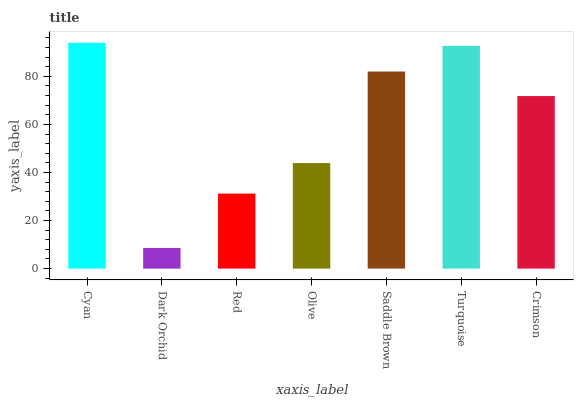Is Dark Orchid the minimum?
Answer yes or no. Yes. Is Cyan the maximum?
Answer yes or no. Yes. Is Red the minimum?
Answer yes or no. No. Is Red the maximum?
Answer yes or no. No. Is Red greater than Dark Orchid?
Answer yes or no. Yes. Is Dark Orchid less than Red?
Answer yes or no. Yes. Is Dark Orchid greater than Red?
Answer yes or no. No. Is Red less than Dark Orchid?
Answer yes or no. No. Is Crimson the high median?
Answer yes or no. Yes. Is Crimson the low median?
Answer yes or no. Yes. Is Turquoise the high median?
Answer yes or no. No. Is Saddle Brown the low median?
Answer yes or no. No. 